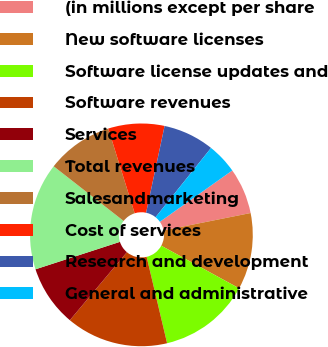<chart> <loc_0><loc_0><loc_500><loc_500><pie_chart><fcel>(in millions except per share<fcel>New software licenses<fcel>Software license updates and<fcel>Software revenues<fcel>Services<fcel>Total revenues<fcel>Salesandmarketing<fcel>Cost of services<fcel>Research and development<fcel>General and administrative<nl><fcel>6.67%<fcel>11.11%<fcel>13.33%<fcel>14.81%<fcel>8.89%<fcel>15.56%<fcel>9.63%<fcel>8.15%<fcel>7.41%<fcel>4.44%<nl></chart> 